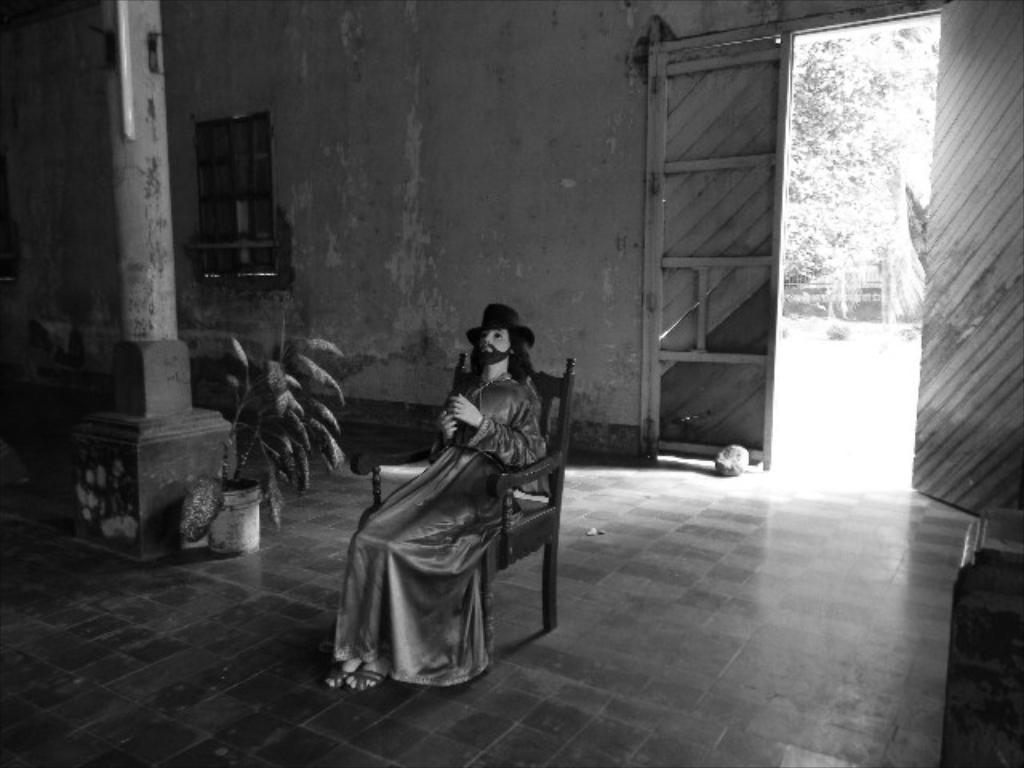Can you describe this image briefly? In this image I can see the person sitting on the chair. The person is wearing the dress and the hat. To the left I can see the flower pot and the pole. In the back I can see the window and the door. I can also see many trees in the back. And this is a black and white image. 